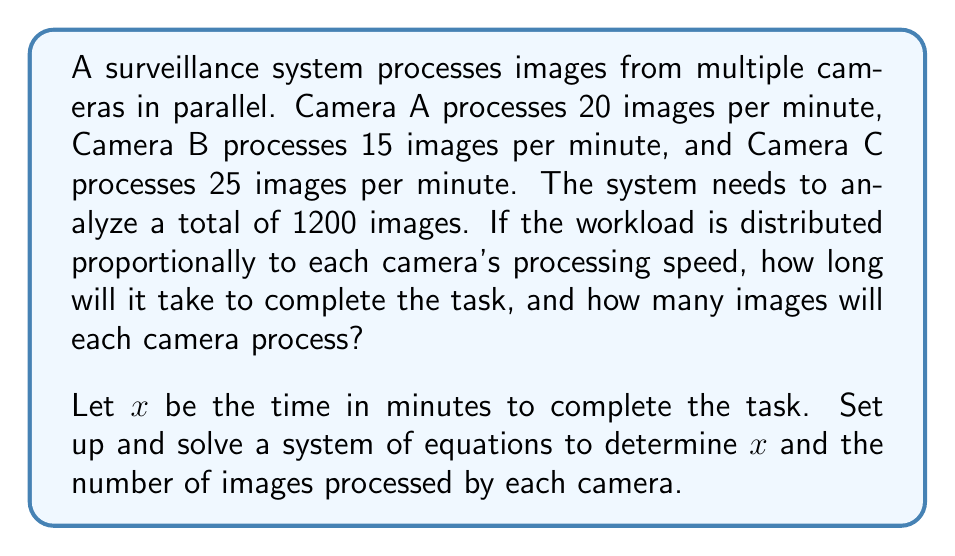Teach me how to tackle this problem. Let's approach this step-by-step:

1) First, let's define variables:
   $a$ = number of images processed by Camera A
   $b$ = number of images processed by Camera B
   $c$ = number of images processed by Camera C
   $x$ = time in minutes to complete the task

2) We know that the total number of images is 1200, so:

   $$a + b + c = 1200$$

3) The number of images processed by each camera is proportional to its processing speed:

   Camera A: $a = 20x$
   Camera B: $b = 15x$
   Camera C: $c = 25x$

4) Substituting these into our first equation:

   $$20x + 15x + 25x = 1200$$

5) Simplify:

   $$60x = 1200$$

6) Solve for $x$:

   $$x = 1200 / 60 = 20$$

7) Now that we know $x$, we can calculate the number of images processed by each camera:

   Camera A: $a = 20 * 20 = 400$
   Camera B: $b = 15 * 20 = 300$
   Camera C: $c = 25 * 20 = 500$

8) Verify: $400 + 300 + 500 = 1200$, which matches our total.
Answer: The task will take 20 minutes to complete. Camera A will process 400 images, Camera B will process 300 images, and Camera C will process 500 images. 